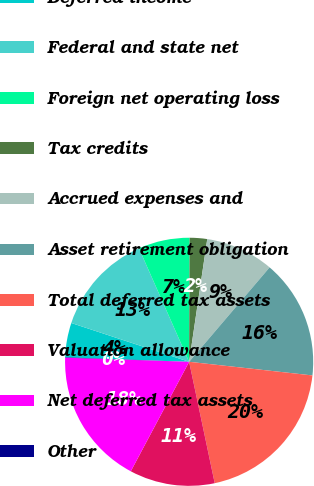Convert chart to OTSL. <chart><loc_0><loc_0><loc_500><loc_500><pie_chart><fcel>Deferred income<fcel>Federal and state net<fcel>Foreign net operating loss<fcel>Tax credits<fcel>Accrued expenses and<fcel>Asset retirement obligation<fcel>Total deferred tax assets<fcel>Valuation allowance<fcel>Net deferred tax assets<fcel>Other<nl><fcel>4.48%<fcel>13.31%<fcel>6.69%<fcel>2.27%<fcel>8.9%<fcel>15.52%<fcel>19.94%<fcel>11.1%<fcel>17.73%<fcel>0.06%<nl></chart> 